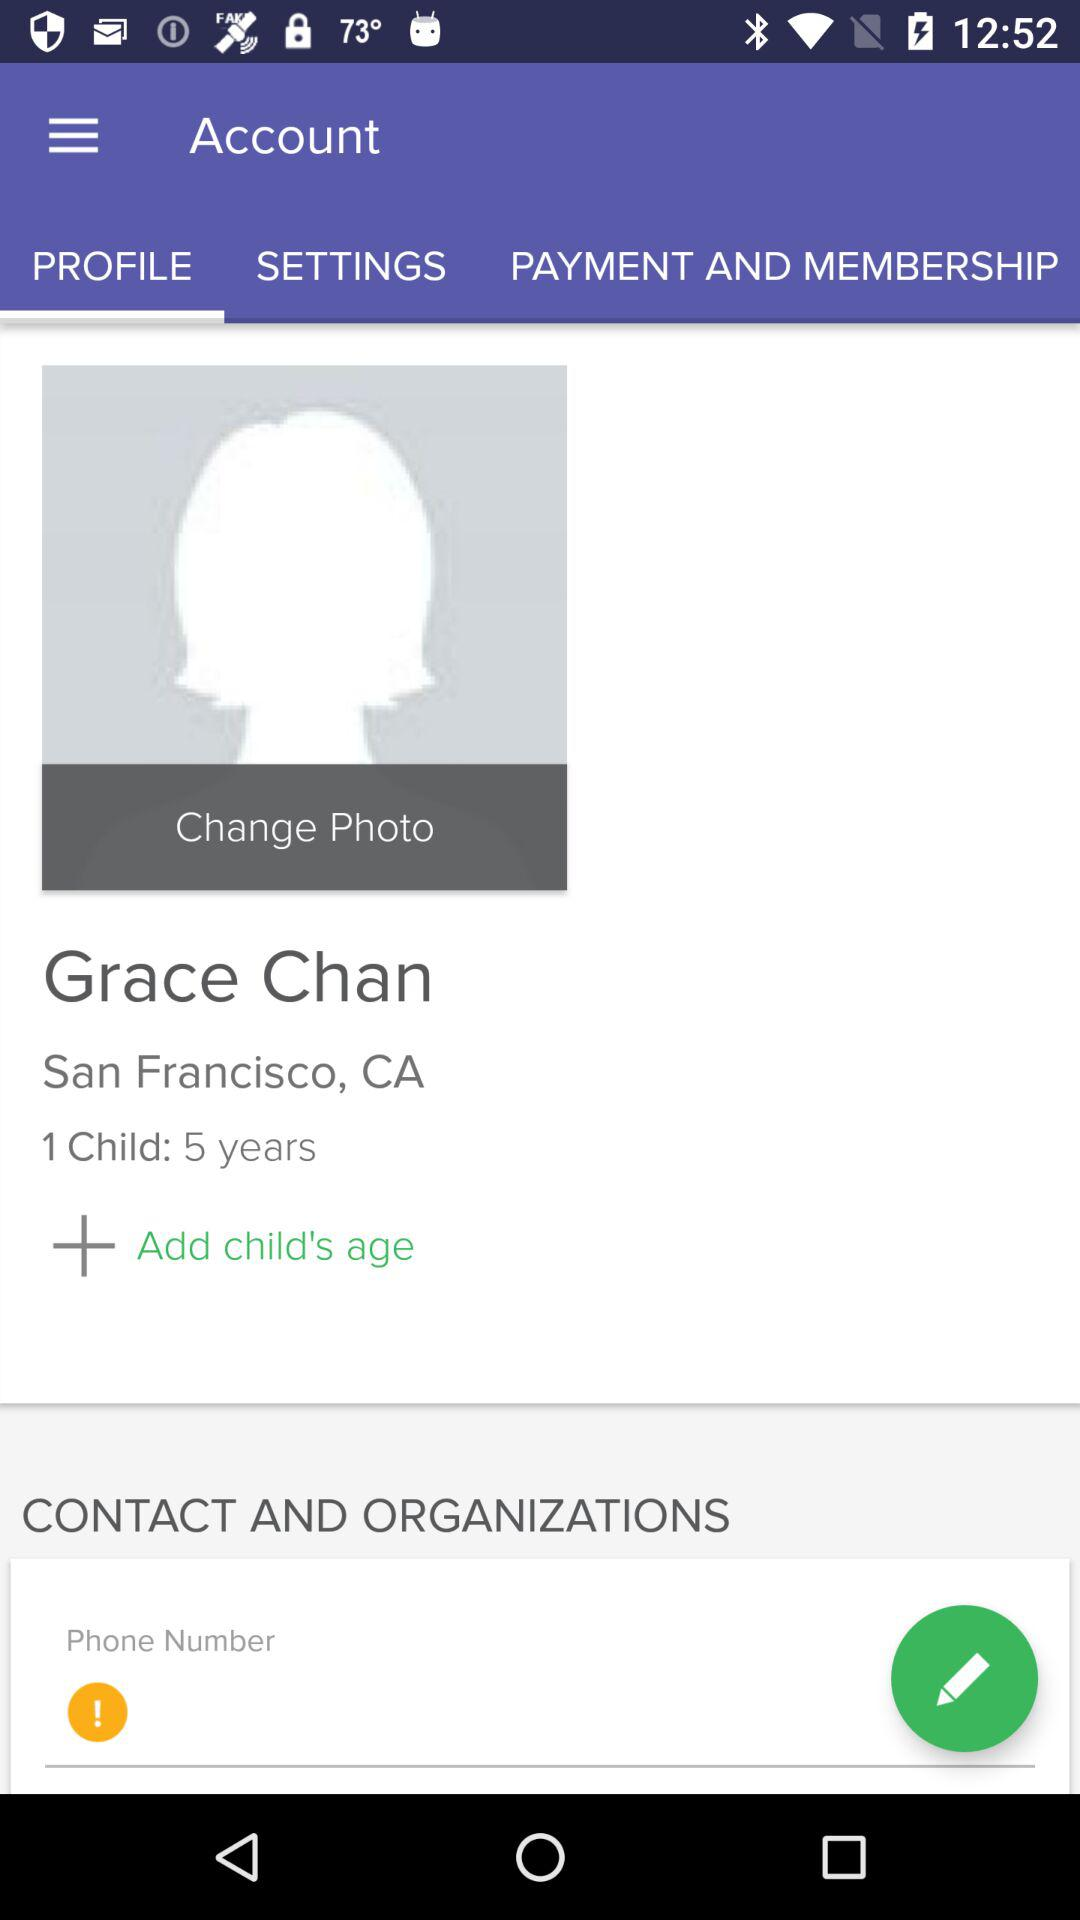What is the location of Grace? The location of Grace is San Francisco, CA. 